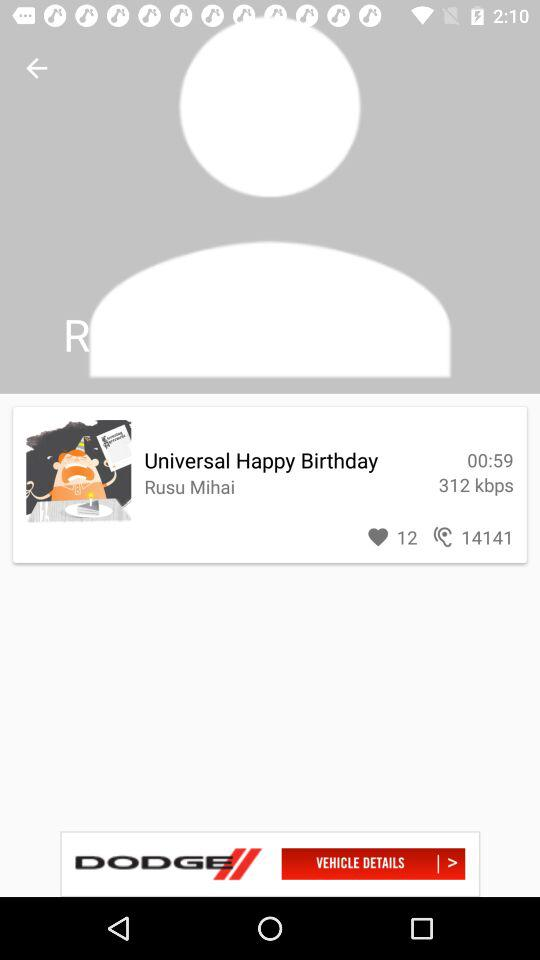How many likes are given? There are 12 likes. 